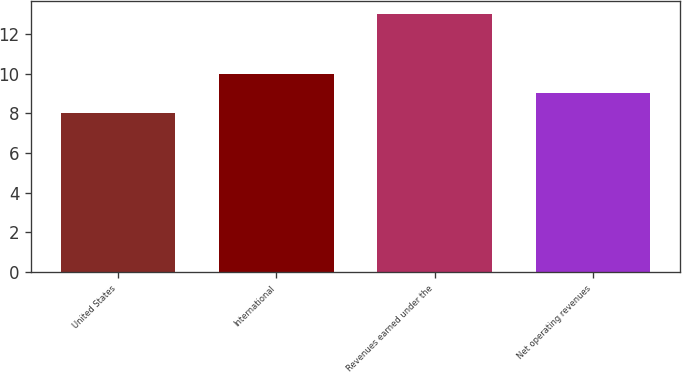Convert chart to OTSL. <chart><loc_0><loc_0><loc_500><loc_500><bar_chart><fcel>United States<fcel>International<fcel>Revenues earned under the<fcel>Net operating revenues<nl><fcel>8<fcel>10<fcel>13<fcel>9<nl></chart> 